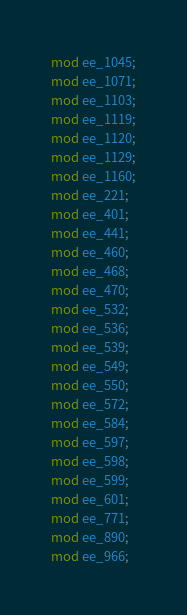Convert code to text. <code><loc_0><loc_0><loc_500><loc_500><_Rust_>mod ee_1045;
mod ee_1071;
mod ee_1103;
mod ee_1119;
mod ee_1120;
mod ee_1129;
mod ee_1160;
mod ee_221;
mod ee_401;
mod ee_441;
mod ee_460;
mod ee_468;
mod ee_470;
mod ee_532;
mod ee_536;
mod ee_539;
mod ee_549;
mod ee_550;
mod ee_572;
mod ee_584;
mod ee_597;
mod ee_598;
mod ee_599;
mod ee_601;
mod ee_771;
mod ee_890;
mod ee_966;
</code> 